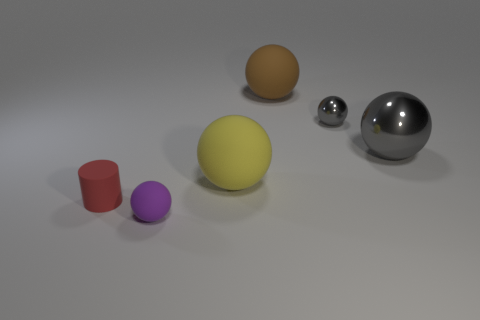What is the material of the other gray thing that is the same shape as the large metal object?
Keep it short and to the point. Metal. Is the small metallic object the same color as the large metallic sphere?
Make the answer very short. Yes. The small rubber object that is to the right of the rubber thing that is to the left of the small rubber sphere is what shape?
Your answer should be very brief. Sphere. What is the shape of the small gray object that is the same material as the big gray object?
Your answer should be compact. Sphere. What number of other objects are there of the same shape as the yellow matte object?
Provide a short and direct response. 4. There is a rubber ball behind the yellow rubber ball; is it the same size as the tiny purple matte object?
Ensure brevity in your answer.  No. Are there more shiny balls that are behind the big gray ball than tiny blue things?
Provide a short and direct response. Yes. There is a tiny ball that is right of the large brown ball; what number of small purple rubber balls are on the left side of it?
Keep it short and to the point. 1. Are there fewer red matte objects that are on the right side of the brown matte object than red rubber objects?
Make the answer very short. Yes. Are there any big gray metallic balls that are in front of the tiny object on the left side of the small rubber thing that is on the right side of the small red cylinder?
Offer a terse response. No. 